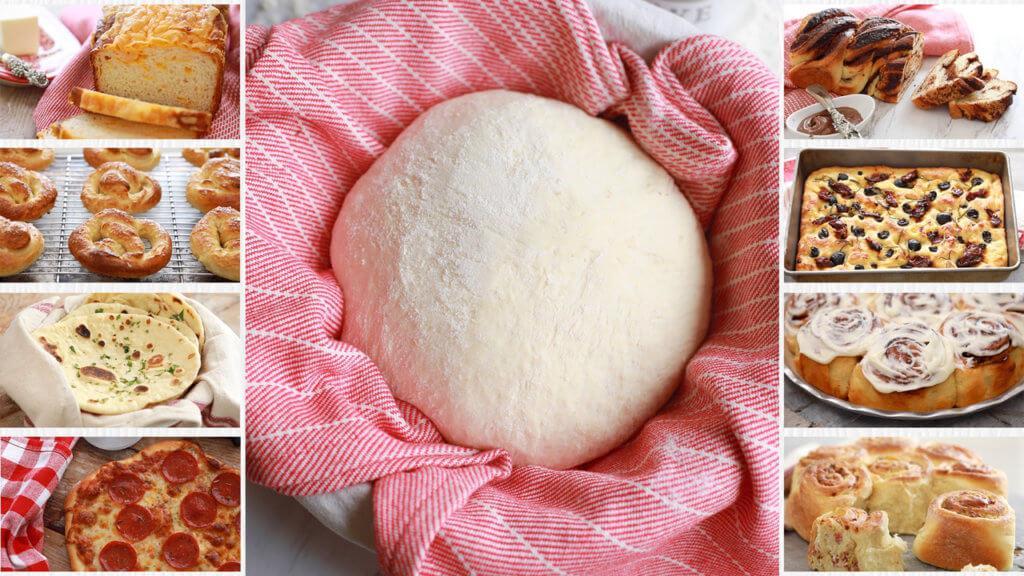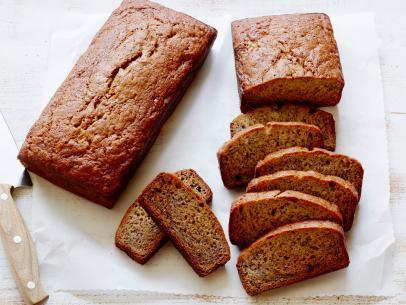The first image is the image on the left, the second image is the image on the right. For the images shown, is this caption "Each image contains at least four different bread items, one image shows breads on unpainted wood, and no image includes unbaked dough." true? Answer yes or no. No. 